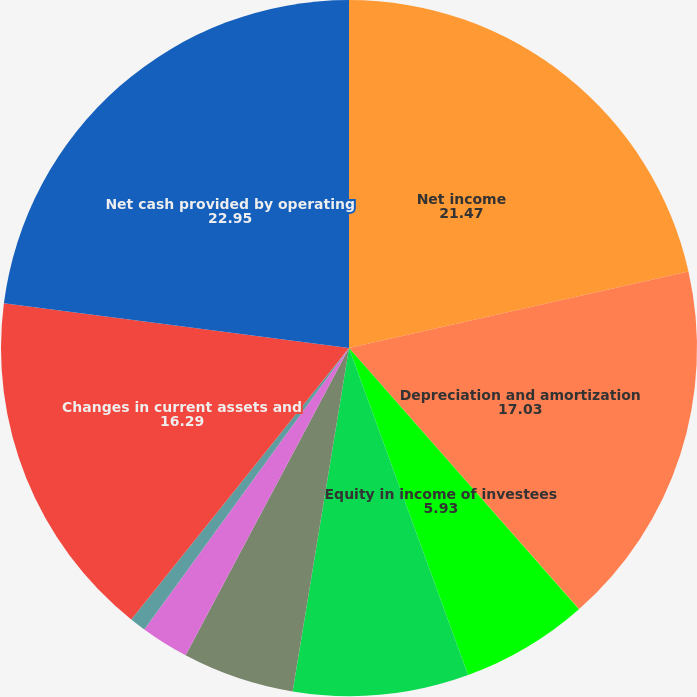Convert chart to OTSL. <chart><loc_0><loc_0><loc_500><loc_500><pie_chart><fcel>Net income<fcel>Depreciation and amortization<fcel>Deferred income tax (benefit)<fcel>Equity in income of investees<fcel>Minority interests in income<fcel>Other post-retirement benefits<fcel>Excess tax benefits on<fcel>Translation and hedging<fcel>Changes in current assets and<fcel>Net cash provided by operating<nl><fcel>21.47%<fcel>17.03%<fcel>0.01%<fcel>5.93%<fcel>8.15%<fcel>5.19%<fcel>2.23%<fcel>0.75%<fcel>16.29%<fcel>22.95%<nl></chart> 